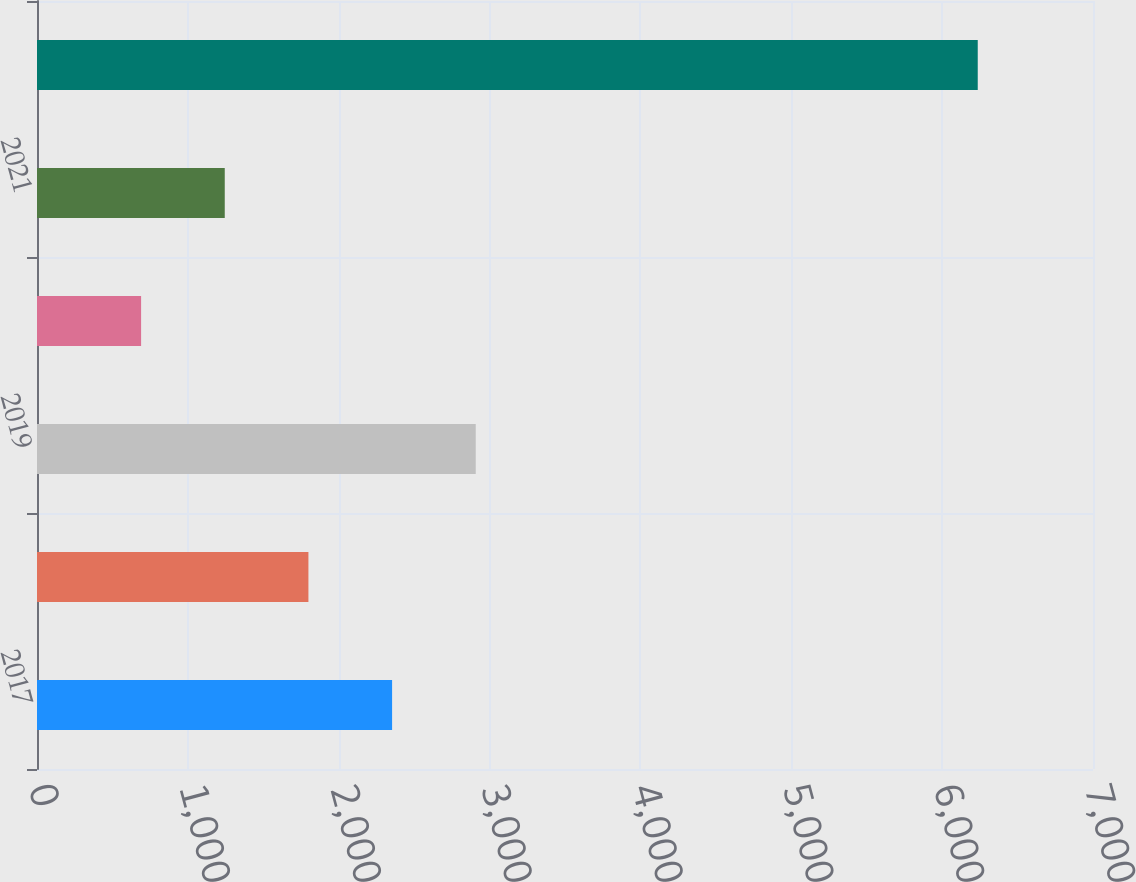Convert chart. <chart><loc_0><loc_0><loc_500><loc_500><bar_chart><fcel>2017<fcel>2018<fcel>2019<fcel>2020<fcel>2021<fcel>Thereafter<nl><fcel>2353.8<fcel>1799.2<fcel>2908.4<fcel>690<fcel>1244.6<fcel>6236<nl></chart> 